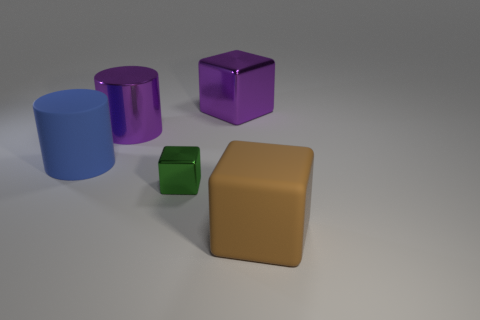Add 3 large blue things. How many objects exist? 8 Subtract all cubes. How many objects are left? 2 Subtract 0 cyan cylinders. How many objects are left? 5 Subtract all small red shiny balls. Subtract all blue matte cylinders. How many objects are left? 4 Add 5 brown matte things. How many brown matte things are left? 6 Add 4 small gray rubber spheres. How many small gray rubber spheres exist? 4 